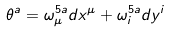Convert formula to latex. <formula><loc_0><loc_0><loc_500><loc_500>\theta ^ { a } = \omega _ { \mu } ^ { 5 a } d x ^ { \mu } + \omega _ { i } ^ { 5 a } d y ^ { i }</formula> 